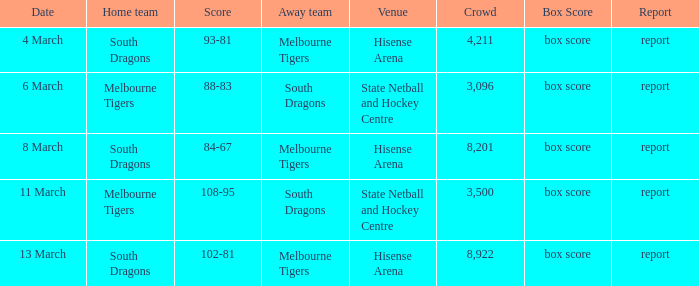Where was the venue with 3,096 in the crowd and against the Melbourne Tigers? Hisense Arena, Hisense Arena, Hisense Arena. 